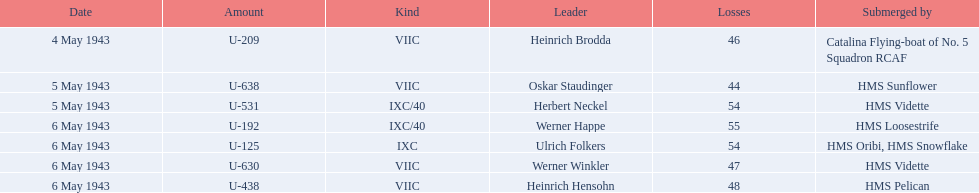What is the list of ships under sunk by? Catalina Flying-boat of No. 5 Squadron RCAF, HMS Sunflower, HMS Vidette, HMS Loosestrife, HMS Oribi, HMS Snowflake, HMS Vidette, HMS Pelican. Which captains did hms pelican sink? Heinrich Hensohn. 